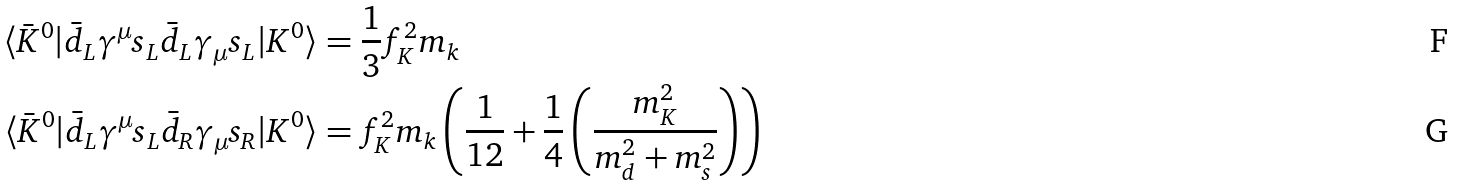<formula> <loc_0><loc_0><loc_500><loc_500>\langle \bar { K } ^ { 0 } | \bar { d } _ { L } \gamma ^ { \mu } s _ { L } \bar { d } _ { L } \gamma _ { \mu } s _ { L } | K ^ { 0 } \rangle & = \frac { 1 } { 3 } f _ { K } ^ { 2 } m _ { k } \\ \langle \bar { K } ^ { 0 } | \bar { d } _ { L } \gamma ^ { \mu } s _ { L } \bar { d } _ { R } \gamma _ { \mu } s _ { R } | K ^ { 0 } \rangle & = f _ { K } ^ { 2 } m _ { k } \left ( \frac { 1 } { 1 2 } + \frac { 1 } { 4 } \left ( \frac { m _ { K } ^ { 2 } } { m _ { d } ^ { 2 } + m _ { s } ^ { 2 } } \right ) \right )</formula> 